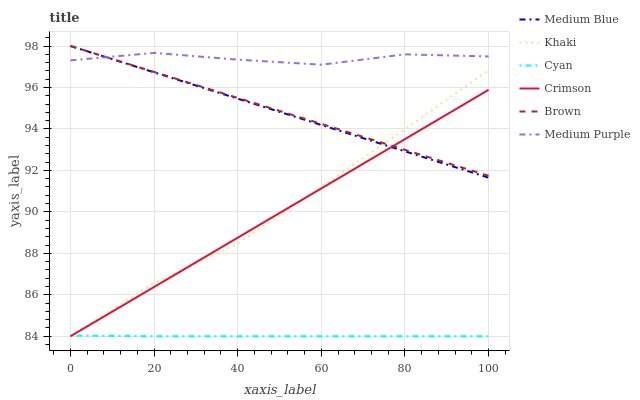Does Cyan have the minimum area under the curve?
Answer yes or no. Yes. Does Medium Purple have the maximum area under the curve?
Answer yes or no. Yes. Does Khaki have the minimum area under the curve?
Answer yes or no. No. Does Khaki have the maximum area under the curve?
Answer yes or no. No. Is Crimson the smoothest?
Answer yes or no. Yes. Is Medium Purple the roughest?
Answer yes or no. Yes. Is Khaki the smoothest?
Answer yes or no. No. Is Khaki the roughest?
Answer yes or no. No. Does Khaki have the lowest value?
Answer yes or no. Yes. Does Medium Blue have the lowest value?
Answer yes or no. No. Does Medium Blue have the highest value?
Answer yes or no. Yes. Does Khaki have the highest value?
Answer yes or no. No. Is Cyan less than Medium Purple?
Answer yes or no. Yes. Is Medium Blue greater than Cyan?
Answer yes or no. Yes. Does Crimson intersect Medium Blue?
Answer yes or no. Yes. Is Crimson less than Medium Blue?
Answer yes or no. No. Is Crimson greater than Medium Blue?
Answer yes or no. No. Does Cyan intersect Medium Purple?
Answer yes or no. No. 